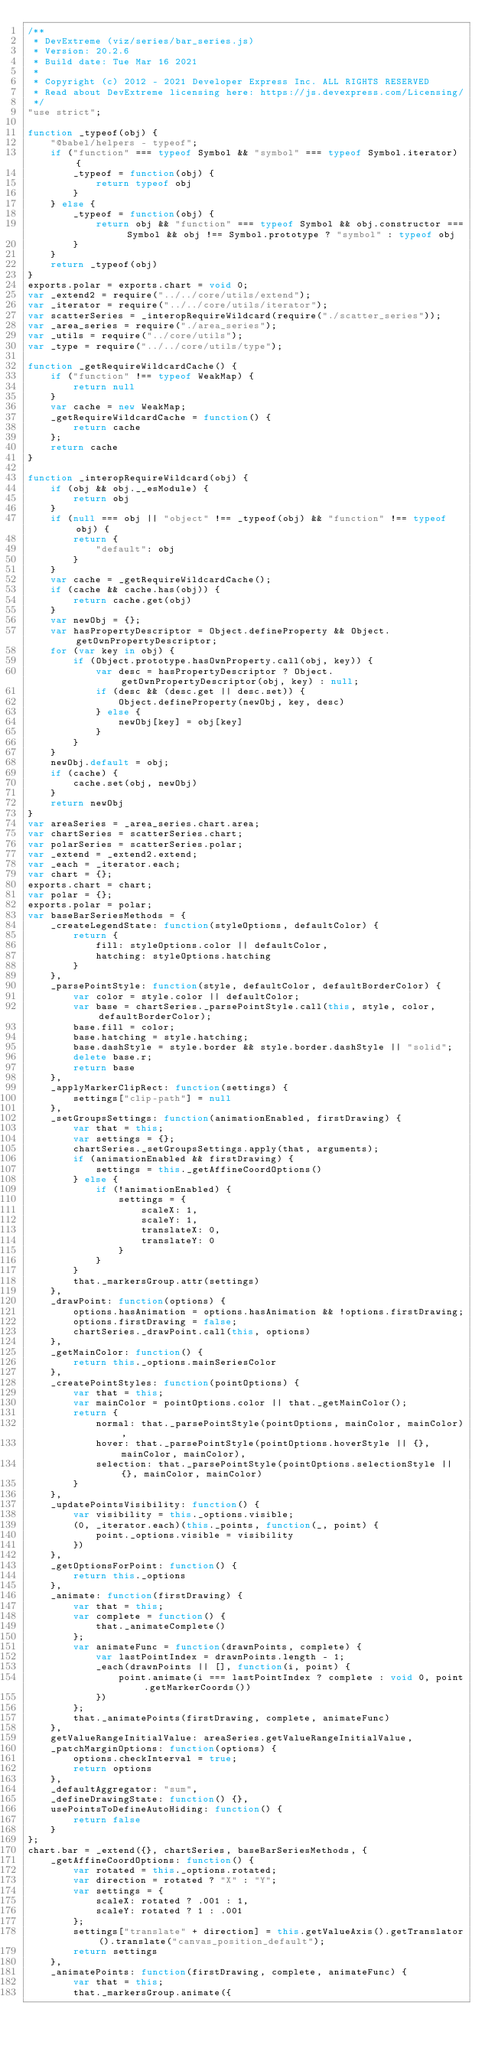<code> <loc_0><loc_0><loc_500><loc_500><_JavaScript_>/**
 * DevExtreme (viz/series/bar_series.js)
 * Version: 20.2.6
 * Build date: Tue Mar 16 2021
 *
 * Copyright (c) 2012 - 2021 Developer Express Inc. ALL RIGHTS RESERVED
 * Read about DevExtreme licensing here: https://js.devexpress.com/Licensing/
 */
"use strict";

function _typeof(obj) {
    "@babel/helpers - typeof";
    if ("function" === typeof Symbol && "symbol" === typeof Symbol.iterator) {
        _typeof = function(obj) {
            return typeof obj
        }
    } else {
        _typeof = function(obj) {
            return obj && "function" === typeof Symbol && obj.constructor === Symbol && obj !== Symbol.prototype ? "symbol" : typeof obj
        }
    }
    return _typeof(obj)
}
exports.polar = exports.chart = void 0;
var _extend2 = require("../../core/utils/extend");
var _iterator = require("../../core/utils/iterator");
var scatterSeries = _interopRequireWildcard(require("./scatter_series"));
var _area_series = require("./area_series");
var _utils = require("../core/utils");
var _type = require("../../core/utils/type");

function _getRequireWildcardCache() {
    if ("function" !== typeof WeakMap) {
        return null
    }
    var cache = new WeakMap;
    _getRequireWildcardCache = function() {
        return cache
    };
    return cache
}

function _interopRequireWildcard(obj) {
    if (obj && obj.__esModule) {
        return obj
    }
    if (null === obj || "object" !== _typeof(obj) && "function" !== typeof obj) {
        return {
            "default": obj
        }
    }
    var cache = _getRequireWildcardCache();
    if (cache && cache.has(obj)) {
        return cache.get(obj)
    }
    var newObj = {};
    var hasPropertyDescriptor = Object.defineProperty && Object.getOwnPropertyDescriptor;
    for (var key in obj) {
        if (Object.prototype.hasOwnProperty.call(obj, key)) {
            var desc = hasPropertyDescriptor ? Object.getOwnPropertyDescriptor(obj, key) : null;
            if (desc && (desc.get || desc.set)) {
                Object.defineProperty(newObj, key, desc)
            } else {
                newObj[key] = obj[key]
            }
        }
    }
    newObj.default = obj;
    if (cache) {
        cache.set(obj, newObj)
    }
    return newObj
}
var areaSeries = _area_series.chart.area;
var chartSeries = scatterSeries.chart;
var polarSeries = scatterSeries.polar;
var _extend = _extend2.extend;
var _each = _iterator.each;
var chart = {};
exports.chart = chart;
var polar = {};
exports.polar = polar;
var baseBarSeriesMethods = {
    _createLegendState: function(styleOptions, defaultColor) {
        return {
            fill: styleOptions.color || defaultColor,
            hatching: styleOptions.hatching
        }
    },
    _parsePointStyle: function(style, defaultColor, defaultBorderColor) {
        var color = style.color || defaultColor;
        var base = chartSeries._parsePointStyle.call(this, style, color, defaultBorderColor);
        base.fill = color;
        base.hatching = style.hatching;
        base.dashStyle = style.border && style.border.dashStyle || "solid";
        delete base.r;
        return base
    },
    _applyMarkerClipRect: function(settings) {
        settings["clip-path"] = null
    },
    _setGroupsSettings: function(animationEnabled, firstDrawing) {
        var that = this;
        var settings = {};
        chartSeries._setGroupsSettings.apply(that, arguments);
        if (animationEnabled && firstDrawing) {
            settings = this._getAffineCoordOptions()
        } else {
            if (!animationEnabled) {
                settings = {
                    scaleX: 1,
                    scaleY: 1,
                    translateX: 0,
                    translateY: 0
                }
            }
        }
        that._markersGroup.attr(settings)
    },
    _drawPoint: function(options) {
        options.hasAnimation = options.hasAnimation && !options.firstDrawing;
        options.firstDrawing = false;
        chartSeries._drawPoint.call(this, options)
    },
    _getMainColor: function() {
        return this._options.mainSeriesColor
    },
    _createPointStyles: function(pointOptions) {
        var that = this;
        var mainColor = pointOptions.color || that._getMainColor();
        return {
            normal: that._parsePointStyle(pointOptions, mainColor, mainColor),
            hover: that._parsePointStyle(pointOptions.hoverStyle || {}, mainColor, mainColor),
            selection: that._parsePointStyle(pointOptions.selectionStyle || {}, mainColor, mainColor)
        }
    },
    _updatePointsVisibility: function() {
        var visibility = this._options.visible;
        (0, _iterator.each)(this._points, function(_, point) {
            point._options.visible = visibility
        })
    },
    _getOptionsForPoint: function() {
        return this._options
    },
    _animate: function(firstDrawing) {
        var that = this;
        var complete = function() {
            that._animateComplete()
        };
        var animateFunc = function(drawnPoints, complete) {
            var lastPointIndex = drawnPoints.length - 1;
            _each(drawnPoints || [], function(i, point) {
                point.animate(i === lastPointIndex ? complete : void 0, point.getMarkerCoords())
            })
        };
        that._animatePoints(firstDrawing, complete, animateFunc)
    },
    getValueRangeInitialValue: areaSeries.getValueRangeInitialValue,
    _patchMarginOptions: function(options) {
        options.checkInterval = true;
        return options
    },
    _defaultAggregator: "sum",
    _defineDrawingState: function() {},
    usePointsToDefineAutoHiding: function() {
        return false
    }
};
chart.bar = _extend({}, chartSeries, baseBarSeriesMethods, {
    _getAffineCoordOptions: function() {
        var rotated = this._options.rotated;
        var direction = rotated ? "X" : "Y";
        var settings = {
            scaleX: rotated ? .001 : 1,
            scaleY: rotated ? 1 : .001
        };
        settings["translate" + direction] = this.getValueAxis().getTranslator().translate("canvas_position_default");
        return settings
    },
    _animatePoints: function(firstDrawing, complete, animateFunc) {
        var that = this;
        that._markersGroup.animate({</code> 